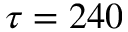<formula> <loc_0><loc_0><loc_500><loc_500>\tau = 2 4 0</formula> 